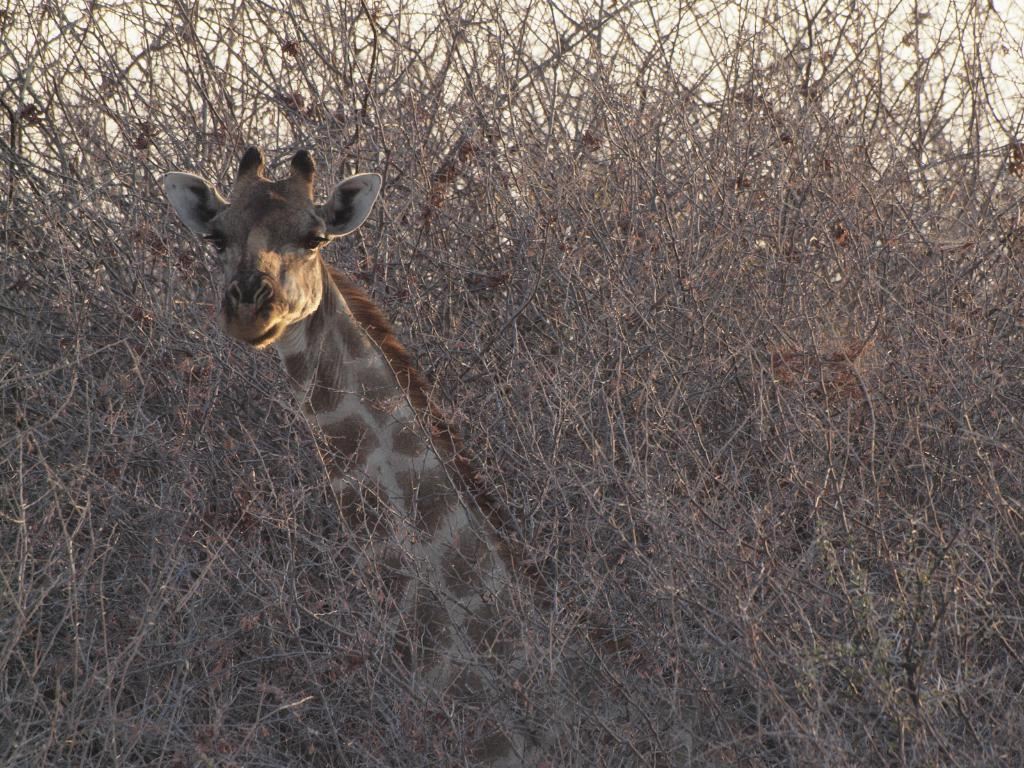What type of living organisms can be seen in the image? Plants are visible in the image. What animal is located in the middle of the image? There is a giraffe in the middle of the image. What type of cough can be heard coming from the giraffe in the in the image? There is no sound, including a cough, present in the image. What type of toys can be seen in the image? There are no toys present in the image; it features plants and a giraffe. 